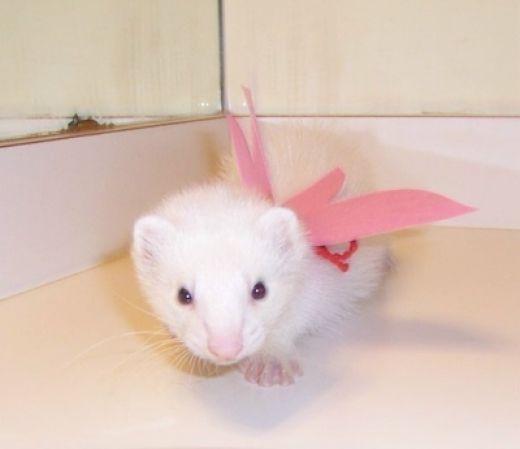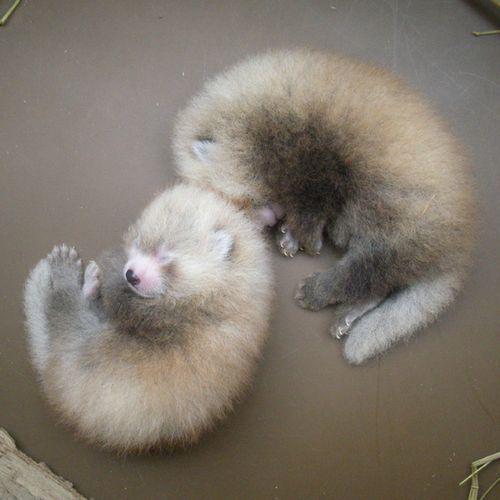The first image is the image on the left, the second image is the image on the right. For the images displayed, is the sentence "The single ferret on the left hand side is dressed up with an accessory while the right hand image shows exactly two ferrets." factually correct? Answer yes or no. Yes. 